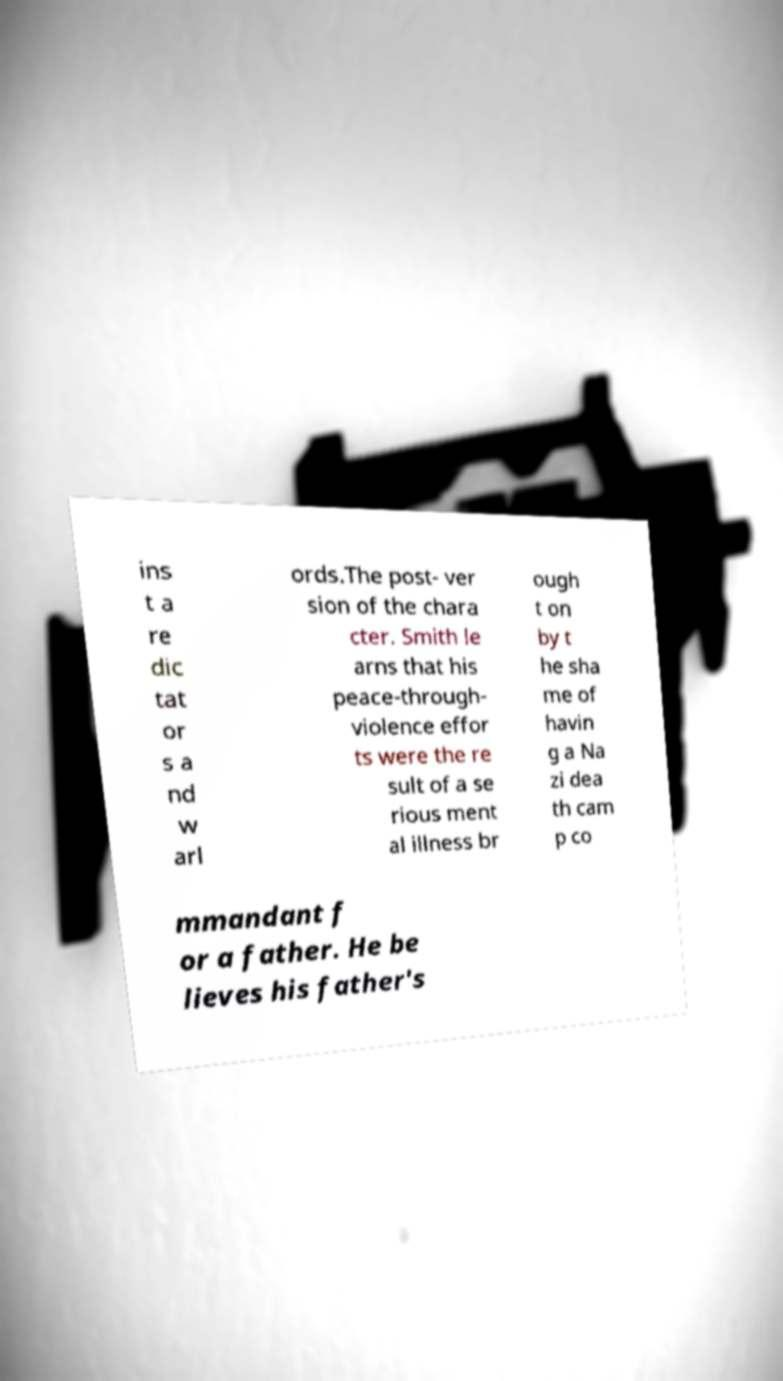What messages or text are displayed in this image? I need them in a readable, typed format. ins t a re dic tat or s a nd w arl ords.The post- ver sion of the chara cter. Smith le arns that his peace-through- violence effor ts were the re sult of a se rious ment al illness br ough t on by t he sha me of havin g a Na zi dea th cam p co mmandant f or a father. He be lieves his father's 